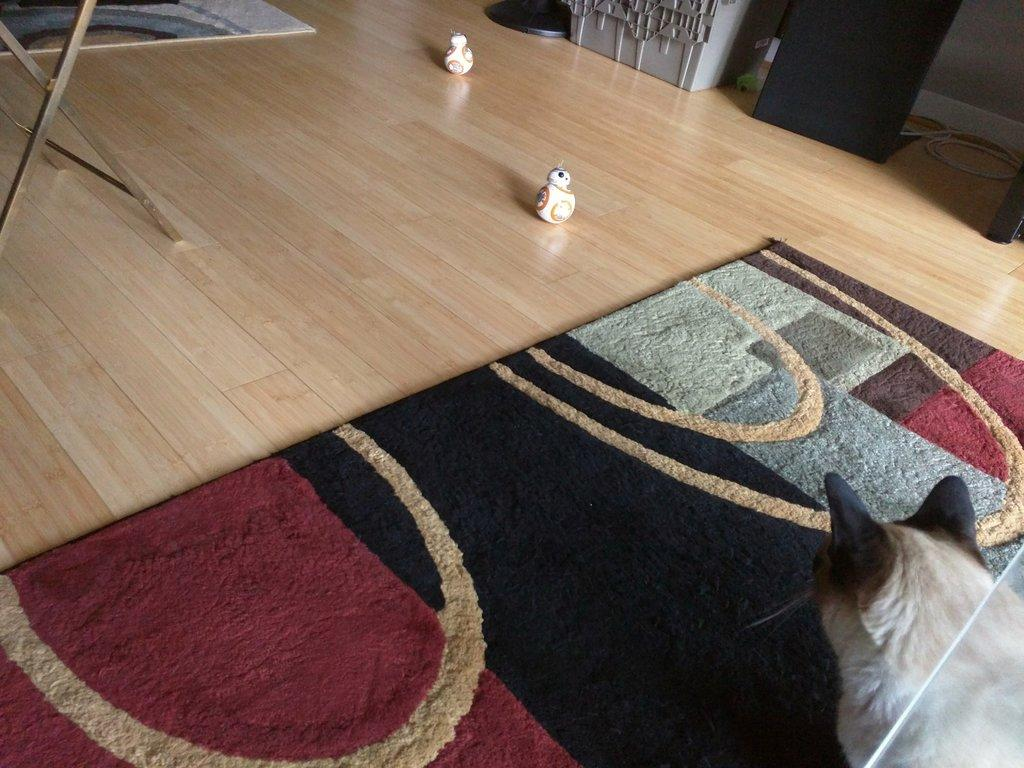What is the main subject in the foreground of the image? There is an animal on a floor mat in the foreground. What else can be seen in the foreground of the image? There is a table and toys on the floor in the foreground. Can you describe the background of the image? The image appears to be taken in a hall, as suggested by the background. How many wheels can be seen on the animal in the image? There are no wheels present on the animal in the image, as animals do not have wheels. 